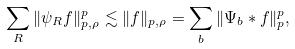Convert formula to latex. <formula><loc_0><loc_0><loc_500><loc_500>\sum _ { R } \| \psi _ { R } f \| _ { p , \rho } ^ { p } \lesssim \| f \| _ { p , \rho } = \sum _ { b } \| \Psi _ { b } \ast f \| _ { p } ^ { p } ,</formula> 